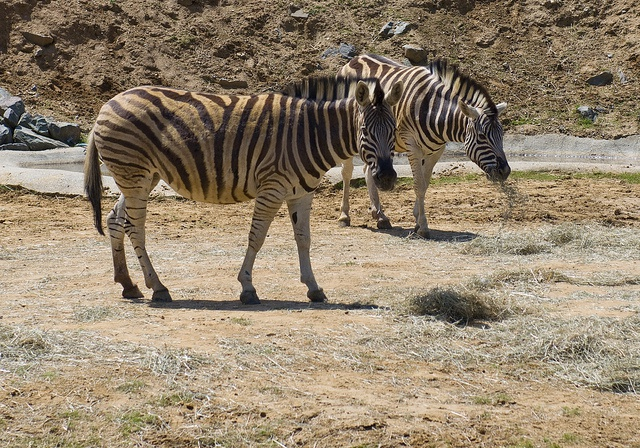Describe the objects in this image and their specific colors. I can see zebra in gray and black tones and zebra in gray and black tones in this image. 